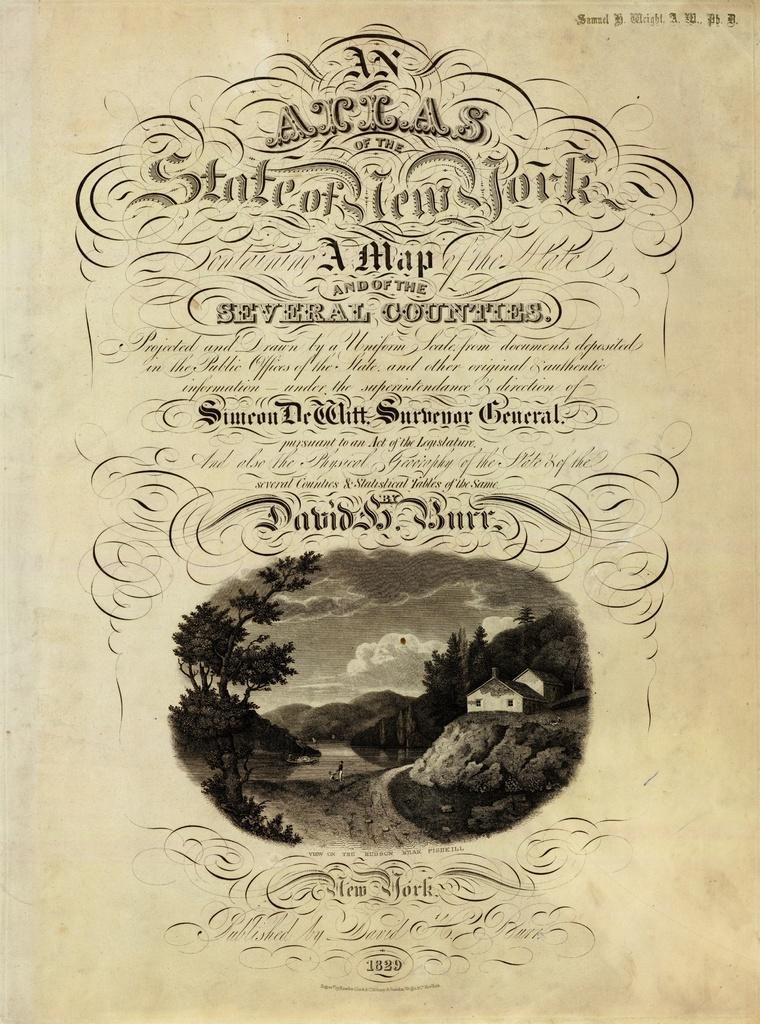What is depicted on the paper in the image? The paper contains a picture of a house. What type of vegetation is visible in the picture? Grass is present in the picture. What is the condition of the sky in the image? The sky is cloudy in the picture. What else can be seen in the picture besides the house and grass? Trees are visible in the picture. Is there any text on the paper? Yes, there is text on the paper. Can you see your aunt holding a kettle in the image? There is no aunt or kettle present in the image. Is there a ghost visible in the picture? There is no ghost present in the image. 